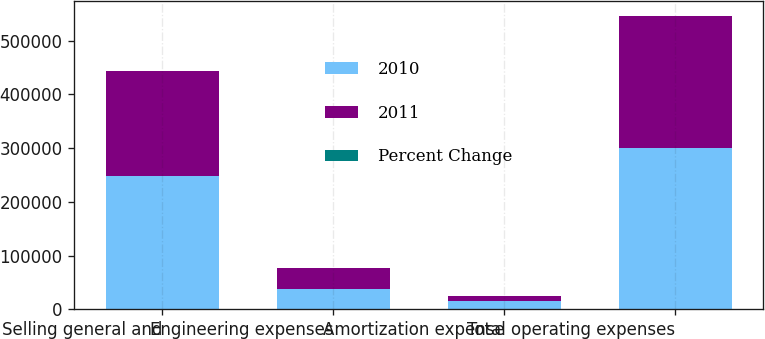Convert chart. <chart><loc_0><loc_0><loc_500><loc_500><stacked_bar_chart><ecel><fcel>Selling general and<fcel>Engineering expenses<fcel>Amortization expense<fcel>Total operating expenses<nl><fcel>2010<fcel>247534<fcel>37193<fcel>14996<fcel>299723<nl><fcel>2011<fcel>195892<fcel>40203<fcel>10173<fcel>246268<nl><fcel>Percent Change<fcel>26.4<fcel>7.5<fcel>47.4<fcel>21.7<nl></chart> 